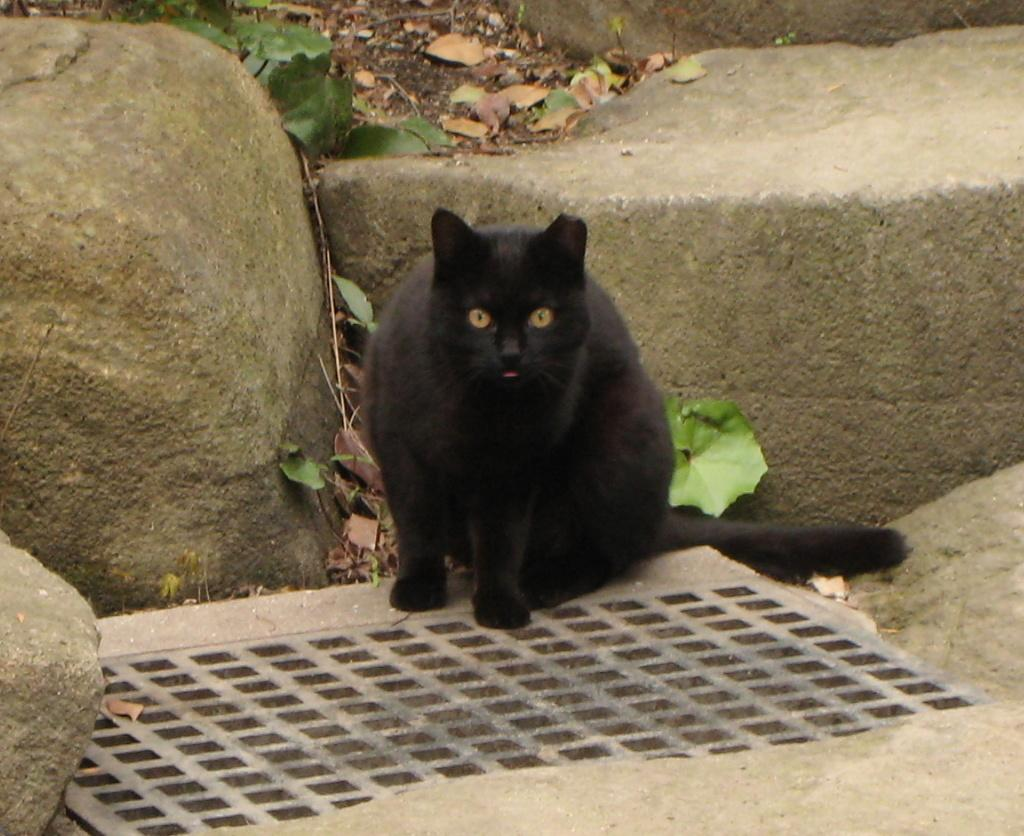What type of animal is in the image? There is a black cat in the image. What is the cat sitting near? The cat is sitting near stones and a steel object. What can be seen at the top of the image? There are green and dry leaves visible at the top of the image. How many frogs are hopping in the field in the image? There are no frogs or fields present in the image; it features a black cat sitting near stones and a steel object, with green and dry leaves visible at the top. 